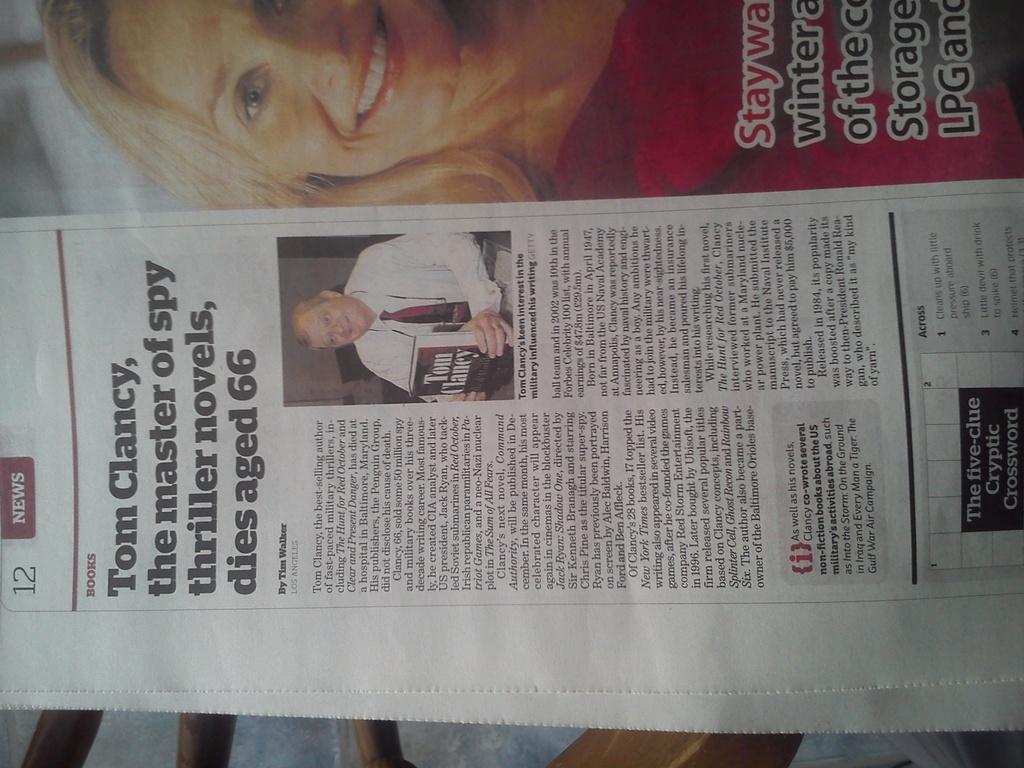Please provide a concise description of this image. In this image there is a newspaper, in that paper there is some text and pictures. 